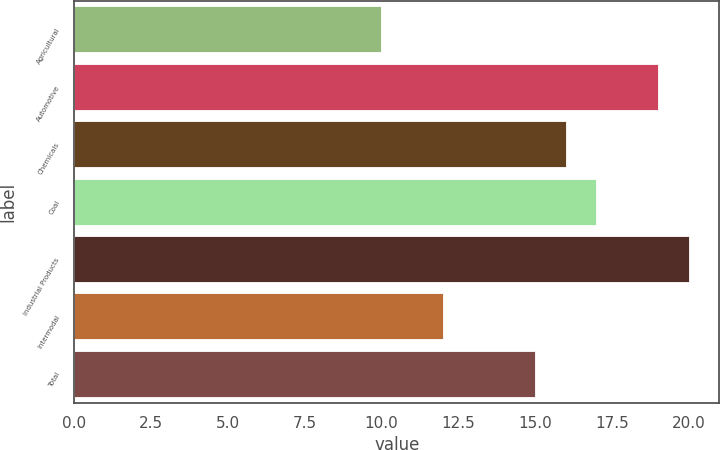Convert chart to OTSL. <chart><loc_0><loc_0><loc_500><loc_500><bar_chart><fcel>Agricultural<fcel>Automotive<fcel>Chemicals<fcel>Coal<fcel>Industrial Products<fcel>Intermodal<fcel>Total<nl><fcel>10<fcel>19<fcel>16<fcel>17<fcel>20<fcel>12<fcel>15<nl></chart> 